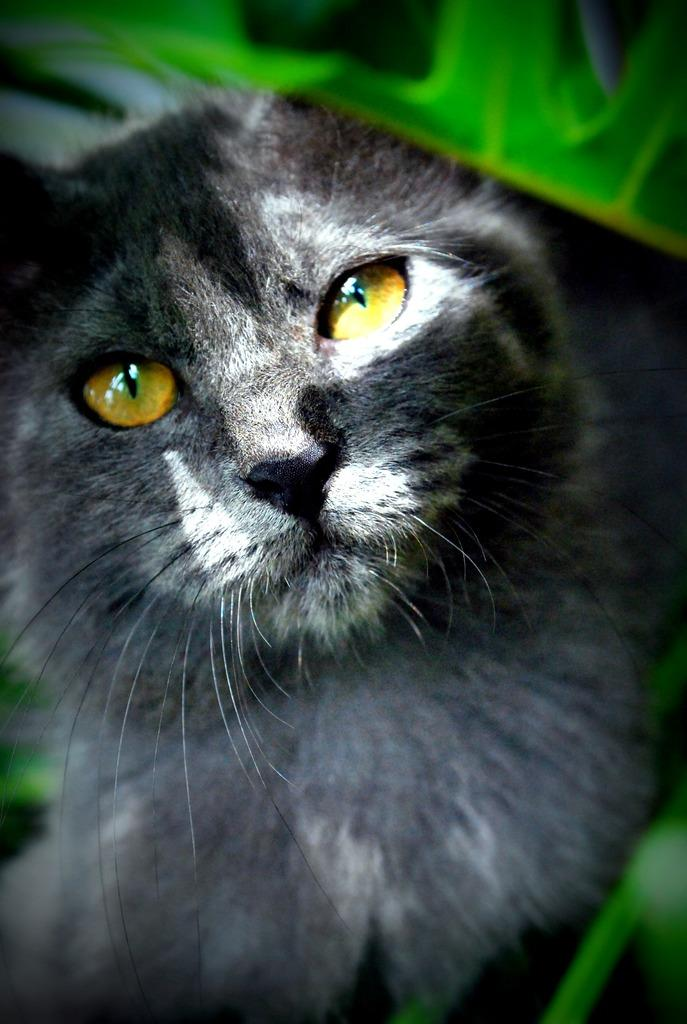What type of animal is in the foreground of the image? There is a black cat in the foreground of the image. What color is the cat? The cat is black. Can you describe any other elements in the image? There is a green element visible in the image. How many silver objects can be seen in the image? There is no mention of silver objects in the image, so we cannot determine the number of silver objects present. 